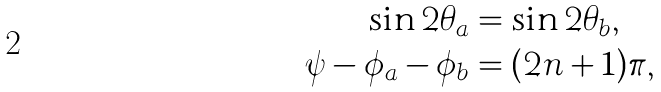<formula> <loc_0><loc_0><loc_500><loc_500>\sin 2 \theta _ { a } & = \sin 2 \theta _ { b } , \\ \psi - \phi _ { a } - \phi _ { b } & = ( 2 n + 1 ) \pi ,</formula> 